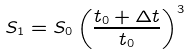<formula> <loc_0><loc_0><loc_500><loc_500>S _ { 1 } = S _ { 0 } \left ( \frac { t _ { 0 } + \Delta t } { t _ { 0 } } \right ) ^ { 3 }</formula> 